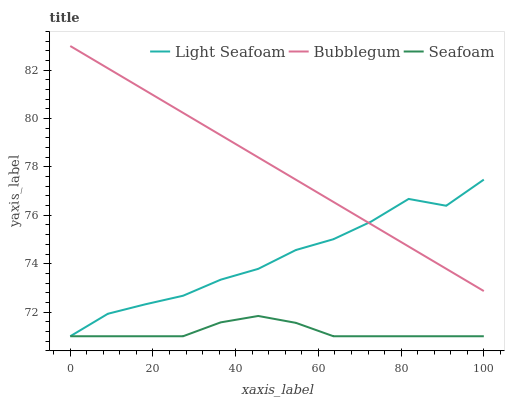Does Seafoam have the minimum area under the curve?
Answer yes or no. Yes. Does Bubblegum have the maximum area under the curve?
Answer yes or no. Yes. Does Bubblegum have the minimum area under the curve?
Answer yes or no. No. Does Seafoam have the maximum area under the curve?
Answer yes or no. No. Is Bubblegum the smoothest?
Answer yes or no. Yes. Is Light Seafoam the roughest?
Answer yes or no. Yes. Is Seafoam the smoothest?
Answer yes or no. No. Is Seafoam the roughest?
Answer yes or no. No. Does Light Seafoam have the lowest value?
Answer yes or no. Yes. Does Bubblegum have the lowest value?
Answer yes or no. No. Does Bubblegum have the highest value?
Answer yes or no. Yes. Does Seafoam have the highest value?
Answer yes or no. No. Is Seafoam less than Bubblegum?
Answer yes or no. Yes. Is Bubblegum greater than Seafoam?
Answer yes or no. Yes. Does Bubblegum intersect Light Seafoam?
Answer yes or no. Yes. Is Bubblegum less than Light Seafoam?
Answer yes or no. No. Is Bubblegum greater than Light Seafoam?
Answer yes or no. No. Does Seafoam intersect Bubblegum?
Answer yes or no. No. 